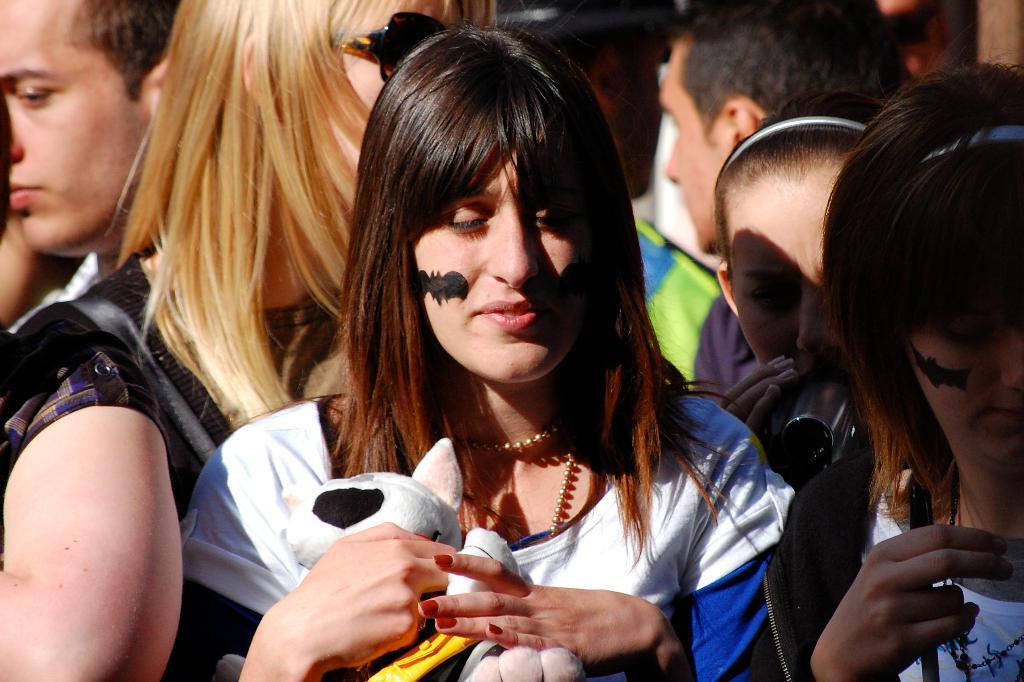Could you give a brief overview of what you see in this image? In this image we can see many people. One lady is holding a doll. She is having a painting of bat on the face. 